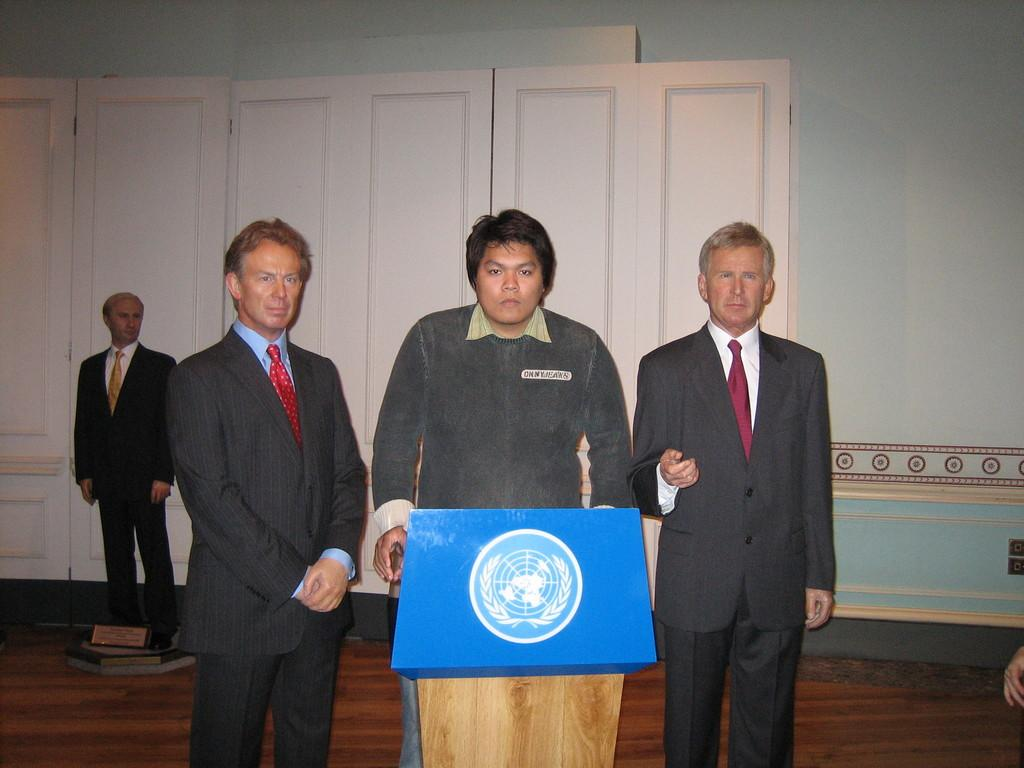What is the person in the image doing? The person is standing in front of a podium. What other objects or figures can be seen in the room? There are three wax statues in the room. What is visible in the background of the image? There is a wall visible in the background. What type of food is being served in a vessel in the image? There is no food or vessel present in the image. 